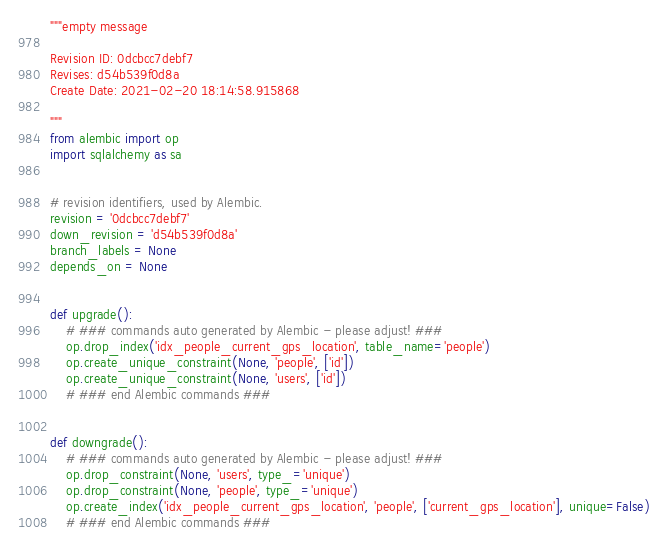Convert code to text. <code><loc_0><loc_0><loc_500><loc_500><_Python_>"""empty message

Revision ID: 0dcbcc7debf7
Revises: d54b539f0d8a
Create Date: 2021-02-20 18:14:58.915868

"""
from alembic import op
import sqlalchemy as sa


# revision identifiers, used by Alembic.
revision = '0dcbcc7debf7'
down_revision = 'd54b539f0d8a'
branch_labels = None
depends_on = None


def upgrade():
    # ### commands auto generated by Alembic - please adjust! ###
    op.drop_index('idx_people_current_gps_location', table_name='people')
    op.create_unique_constraint(None, 'people', ['id'])
    op.create_unique_constraint(None, 'users', ['id'])
    # ### end Alembic commands ###


def downgrade():
    # ### commands auto generated by Alembic - please adjust! ###
    op.drop_constraint(None, 'users', type_='unique')
    op.drop_constraint(None, 'people', type_='unique')
    op.create_index('idx_people_current_gps_location', 'people', ['current_gps_location'], unique=False)
    # ### end Alembic commands ###
</code> 